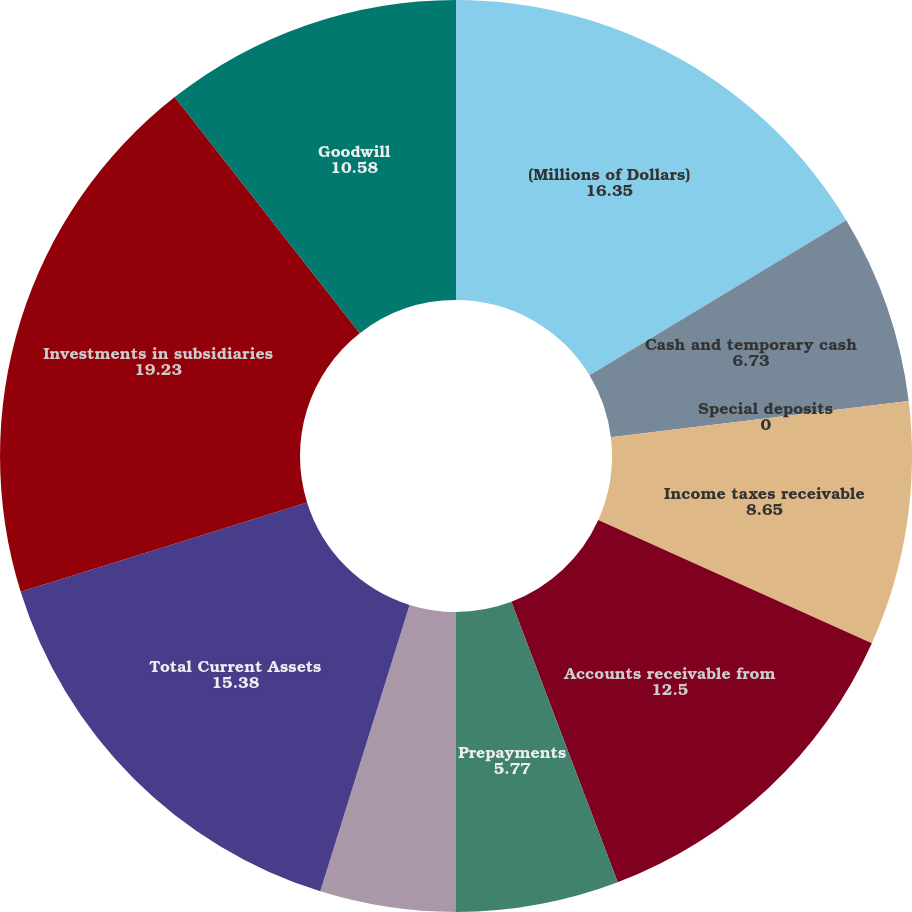Convert chart to OTSL. <chart><loc_0><loc_0><loc_500><loc_500><pie_chart><fcel>(Millions of Dollars)<fcel>Cash and temporary cash<fcel>Special deposits<fcel>Income taxes receivable<fcel>Accounts receivable from<fcel>Prepayments<fcel>Other current assets<fcel>Total Current Assets<fcel>Investments in subsidiaries<fcel>Goodwill<nl><fcel>16.35%<fcel>6.73%<fcel>0.0%<fcel>8.65%<fcel>12.5%<fcel>5.77%<fcel>4.81%<fcel>15.38%<fcel>19.23%<fcel>10.58%<nl></chart> 